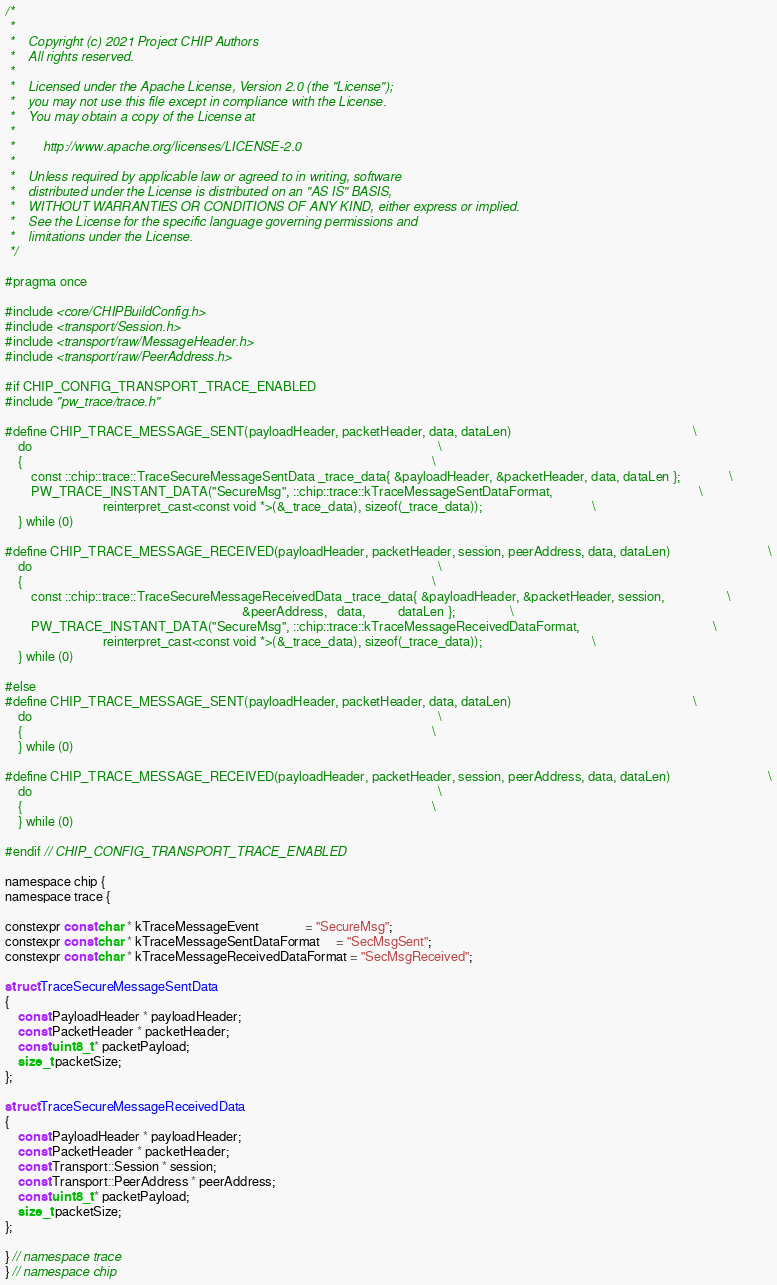<code> <loc_0><loc_0><loc_500><loc_500><_C_>/*
 *
 *    Copyright (c) 2021 Project CHIP Authors
 *    All rights reserved.
 *
 *    Licensed under the Apache License, Version 2.0 (the "License");
 *    you may not use this file except in compliance with the License.
 *    You may obtain a copy of the License at
 *
 *        http://www.apache.org/licenses/LICENSE-2.0
 *
 *    Unless required by applicable law or agreed to in writing, software
 *    distributed under the License is distributed on an "AS IS" BASIS,
 *    WITHOUT WARRANTIES OR CONDITIONS OF ANY KIND, either express or implied.
 *    See the License for the specific language governing permissions and
 *    limitations under the License.
 */

#pragma once

#include <core/CHIPBuildConfig.h>
#include <transport/Session.h>
#include <transport/raw/MessageHeader.h>
#include <transport/raw/PeerAddress.h>

#if CHIP_CONFIG_TRANSPORT_TRACE_ENABLED
#include "pw_trace/trace.h"

#define CHIP_TRACE_MESSAGE_SENT(payloadHeader, packetHeader, data, dataLen)                                                        \
    do                                                                                                                             \
    {                                                                                                                              \
        const ::chip::trace::TraceSecureMessageSentData _trace_data{ &payloadHeader, &packetHeader, data, dataLen };               \
        PW_TRACE_INSTANT_DATA("SecureMsg", ::chip::trace::kTraceMessageSentDataFormat,                                             \
                              reinterpret_cast<const void *>(&_trace_data), sizeof(_trace_data));                                  \
    } while (0)

#define CHIP_TRACE_MESSAGE_RECEIVED(payloadHeader, packetHeader, session, peerAddress, data, dataLen)                              \
    do                                                                                                                             \
    {                                                                                                                              \
        const ::chip::trace::TraceSecureMessageReceivedData _trace_data{ &payloadHeader, &packetHeader, session,                   \
                                                                         &peerAddress,   data,          dataLen };                 \
        PW_TRACE_INSTANT_DATA("SecureMsg", ::chip::trace::kTraceMessageReceivedDataFormat,                                         \
                              reinterpret_cast<const void *>(&_trace_data), sizeof(_trace_data));                                  \
    } while (0)

#else
#define CHIP_TRACE_MESSAGE_SENT(payloadHeader, packetHeader, data, dataLen)                                                        \
    do                                                                                                                             \
    {                                                                                                                              \
    } while (0)

#define CHIP_TRACE_MESSAGE_RECEIVED(payloadHeader, packetHeader, session, peerAddress, data, dataLen)                              \
    do                                                                                                                             \
    {                                                                                                                              \
    } while (0)

#endif // CHIP_CONFIG_TRANSPORT_TRACE_ENABLED

namespace chip {
namespace trace {

constexpr const char * kTraceMessageEvent              = "SecureMsg";
constexpr const char * kTraceMessageSentDataFormat     = "SecMsgSent";
constexpr const char * kTraceMessageReceivedDataFormat = "SecMsgReceived";

struct TraceSecureMessageSentData
{
    const PayloadHeader * payloadHeader;
    const PacketHeader * packetHeader;
    const uint8_t * packetPayload;
    size_t packetSize;
};

struct TraceSecureMessageReceivedData
{
    const PayloadHeader * payloadHeader;
    const PacketHeader * packetHeader;
    const Transport::Session * session;
    const Transport::PeerAddress * peerAddress;
    const uint8_t * packetPayload;
    size_t packetSize;
};

} // namespace trace
} // namespace chip
</code> 